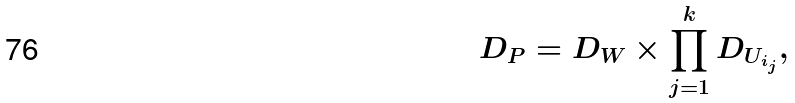<formula> <loc_0><loc_0><loc_500><loc_500>D _ { P } = D _ { W } \times \prod _ { j = 1 } ^ { k } D _ { U _ { i _ { j } } } ,</formula> 